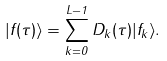<formula> <loc_0><loc_0><loc_500><loc_500>| f ( \tau ) \rangle = \sum _ { k = 0 } ^ { L - 1 } { D } _ { k } ( \tau ) | f _ { k } \rangle .</formula> 